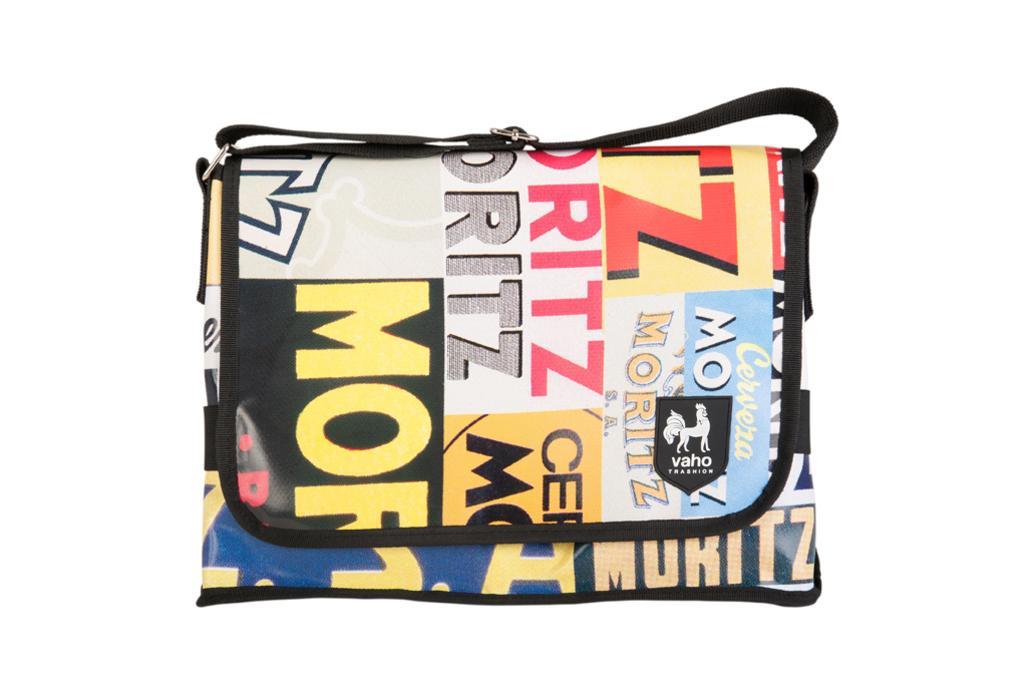What object can be seen in the image? There is a handbag in the image. What is unique about the handbag? There is text written on the handbag. What type of fruit is being served for breakfast in the image? There is no fruit or breakfast scene present in the image; it only features a handbag with text on it. 